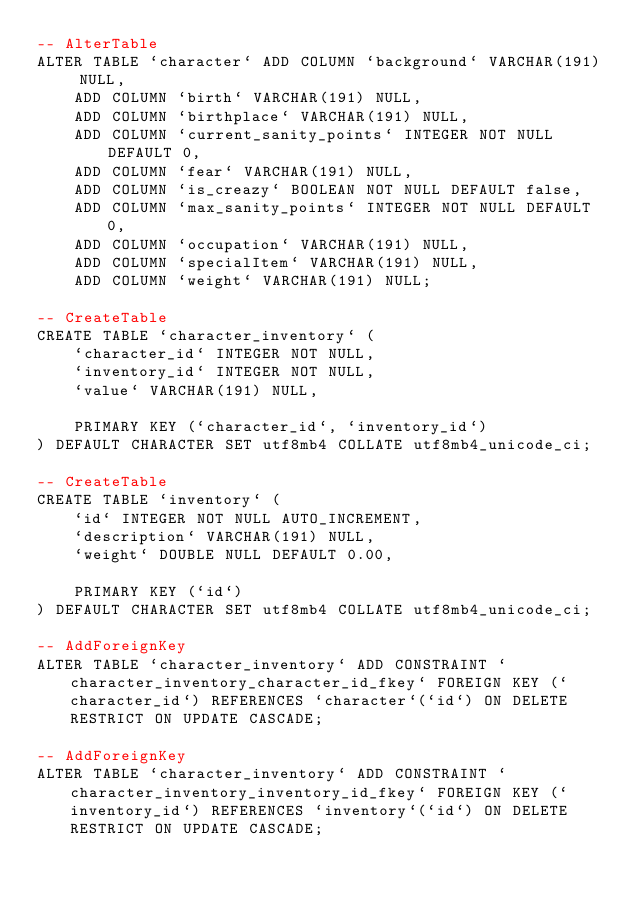<code> <loc_0><loc_0><loc_500><loc_500><_SQL_>-- AlterTable
ALTER TABLE `character` ADD COLUMN `background` VARCHAR(191) NULL,
    ADD COLUMN `birth` VARCHAR(191) NULL,
    ADD COLUMN `birthplace` VARCHAR(191) NULL,
    ADD COLUMN `current_sanity_points` INTEGER NOT NULL DEFAULT 0,
    ADD COLUMN `fear` VARCHAR(191) NULL,
    ADD COLUMN `is_creazy` BOOLEAN NOT NULL DEFAULT false,
    ADD COLUMN `max_sanity_points` INTEGER NOT NULL DEFAULT 0,
    ADD COLUMN `occupation` VARCHAR(191) NULL,
    ADD COLUMN `specialItem` VARCHAR(191) NULL,
    ADD COLUMN `weight` VARCHAR(191) NULL;

-- CreateTable
CREATE TABLE `character_inventory` (
    `character_id` INTEGER NOT NULL,
    `inventory_id` INTEGER NOT NULL,
    `value` VARCHAR(191) NULL,

    PRIMARY KEY (`character_id`, `inventory_id`)
) DEFAULT CHARACTER SET utf8mb4 COLLATE utf8mb4_unicode_ci;

-- CreateTable
CREATE TABLE `inventory` (
    `id` INTEGER NOT NULL AUTO_INCREMENT,
    `description` VARCHAR(191) NULL,
    `weight` DOUBLE NULL DEFAULT 0.00,

    PRIMARY KEY (`id`)
) DEFAULT CHARACTER SET utf8mb4 COLLATE utf8mb4_unicode_ci;

-- AddForeignKey
ALTER TABLE `character_inventory` ADD CONSTRAINT `character_inventory_character_id_fkey` FOREIGN KEY (`character_id`) REFERENCES `character`(`id`) ON DELETE RESTRICT ON UPDATE CASCADE;

-- AddForeignKey
ALTER TABLE `character_inventory` ADD CONSTRAINT `character_inventory_inventory_id_fkey` FOREIGN KEY (`inventory_id`) REFERENCES `inventory`(`id`) ON DELETE RESTRICT ON UPDATE CASCADE;
</code> 